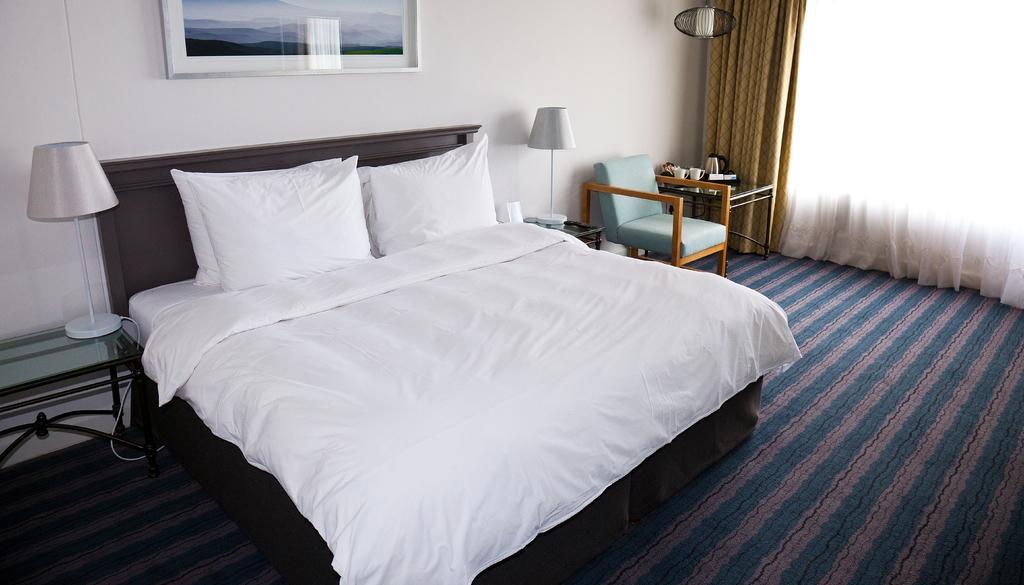How would you summarize this image in a sentence or two? In the center we can see the bed,on bed one bed sheet ,two pillows. And side of bed we can see two lamps on table,one chair. And back we can see wall,frame and curtains. And table on table some objects. 